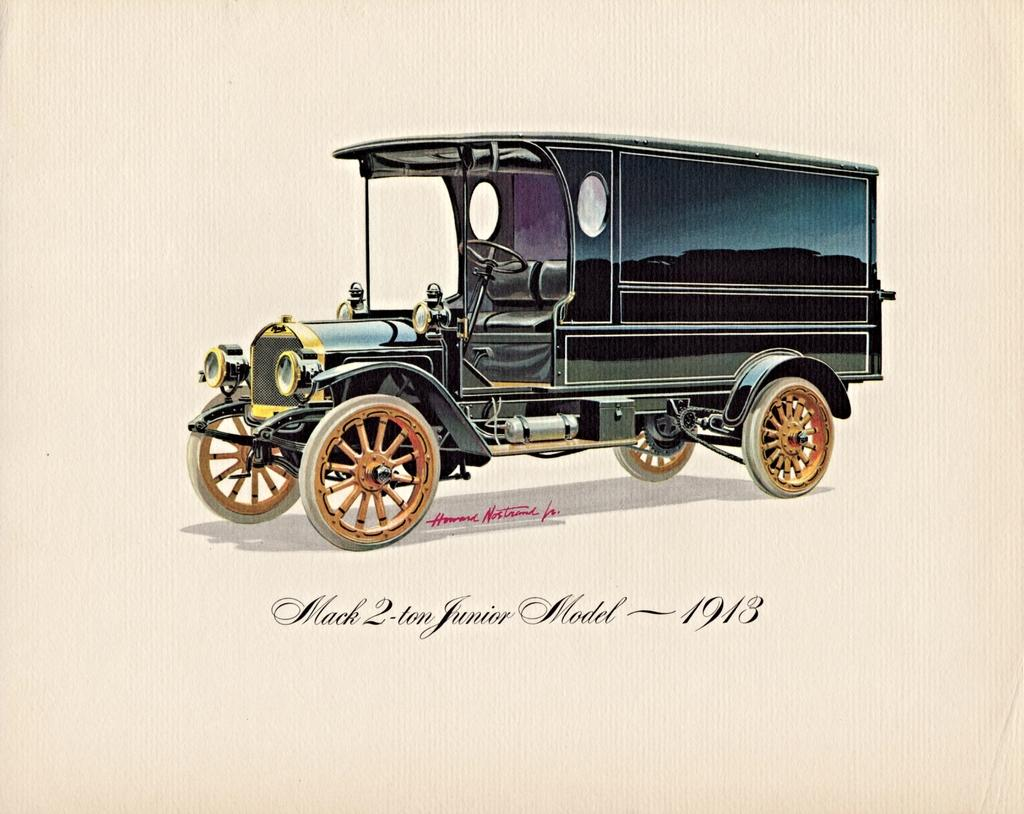What is present on the paper in the image? There is a paper in the image, and it has words, numbers, and an image of a vehicle on it. Can you describe the content of the paper in more detail? The paper contains words, numbers, and an image of a vehicle. What type of vehicle is depicted on the paper? The image on the paper shows a vehicle, but the specific type of vehicle is not mentioned in the facts. What type of whip is being used in the image? There is no mention of a whip in the image or the provided facts. 